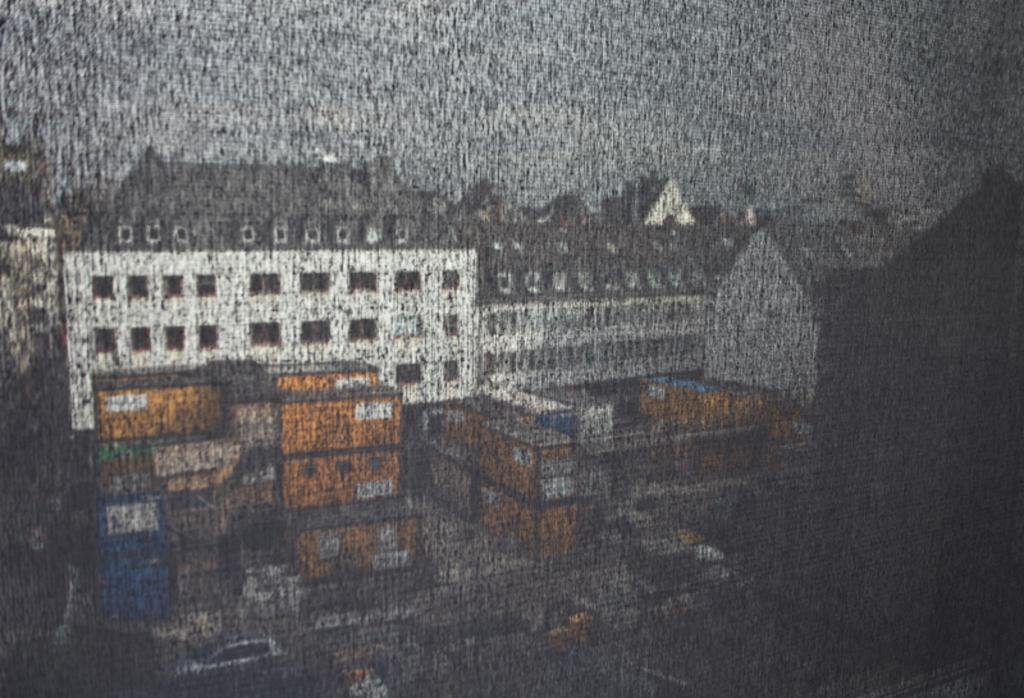What type of structures can be seen in the image? There are buildings in the image. What else can be seen in the image besides buildings? There are roads and cars in the image. How many ants can be seen on the chair in the image? There is no chair or ant present in the image. 